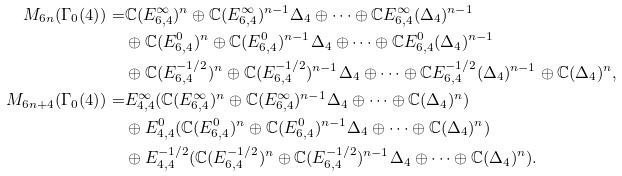Convert formula to latex. <formula><loc_0><loc_0><loc_500><loc_500>M _ { 6 n } ( \Gamma _ { 0 } ( 4 ) ) = & \mathbb { C } ( E _ { 6 , 4 } ^ { \infty } ) ^ { n } \oplus \mathbb { C } ( E _ { 6 , 4 } ^ { \infty } ) ^ { n - 1 } \Delta _ { 4 } \oplus \cdots \oplus \mathbb { C } E _ { 6 , 4 } ^ { \infty } ( \Delta _ { 4 } ) ^ { n - 1 } \\ & \oplus \mathbb { C } ( E _ { 6 , 4 } ^ { 0 } ) ^ { n } \oplus \mathbb { C } ( E _ { 6 , 4 } ^ { 0 } ) ^ { n - 1 } \Delta _ { 4 } \oplus \cdots \oplus \mathbb { C } E _ { 6 , 4 } ^ { 0 } ( \Delta _ { 4 } ) ^ { n - 1 } \\ & \oplus \mathbb { C } ( E _ { 6 , 4 } ^ { - 1 / 2 } ) ^ { n } \oplus \mathbb { C } ( E _ { 6 , 4 } ^ { - 1 / 2 } ) ^ { n - 1 } \Delta _ { 4 } \oplus \cdots \oplus \mathbb { C } E _ { 6 , 4 } ^ { - 1 / 2 } ( \Delta _ { 4 } ) ^ { n - 1 } \oplus \mathbb { C } ( \Delta _ { 4 } ) ^ { n } , \\ M _ { 6 n + 4 } ( \Gamma _ { 0 } ( 4 ) ) = & E _ { 4 , 4 } ^ { \infty } ( \mathbb { C } ( E _ { 6 , 4 } ^ { \infty } ) ^ { n } \oplus \mathbb { C } ( E _ { 6 , 4 } ^ { \infty } ) ^ { n - 1 } \Delta _ { 4 } \oplus \cdots \oplus \mathbb { C } ( \Delta _ { 4 } ) ^ { n } ) \\ & \oplus E _ { 4 , 4 } ^ { 0 } ( \mathbb { C } ( E _ { 6 , 4 } ^ { 0 } ) ^ { n } \oplus \mathbb { C } ( E _ { 6 , 4 } ^ { 0 } ) ^ { n - 1 } \Delta _ { 4 } \oplus \cdots \oplus \mathbb { C } ( \Delta _ { 4 } ) ^ { n } ) \\ & \oplus E _ { 4 , 4 } ^ { - 1 / 2 } ( \mathbb { C } ( E _ { 6 , 4 } ^ { - 1 / 2 } ) ^ { n } \oplus \mathbb { C } ( E _ { 6 , 4 } ^ { - 1 / 2 } ) ^ { n - 1 } \Delta _ { 4 } \oplus \cdots \oplus \mathbb { C } ( \Delta _ { 4 } ) ^ { n } ) .</formula> 